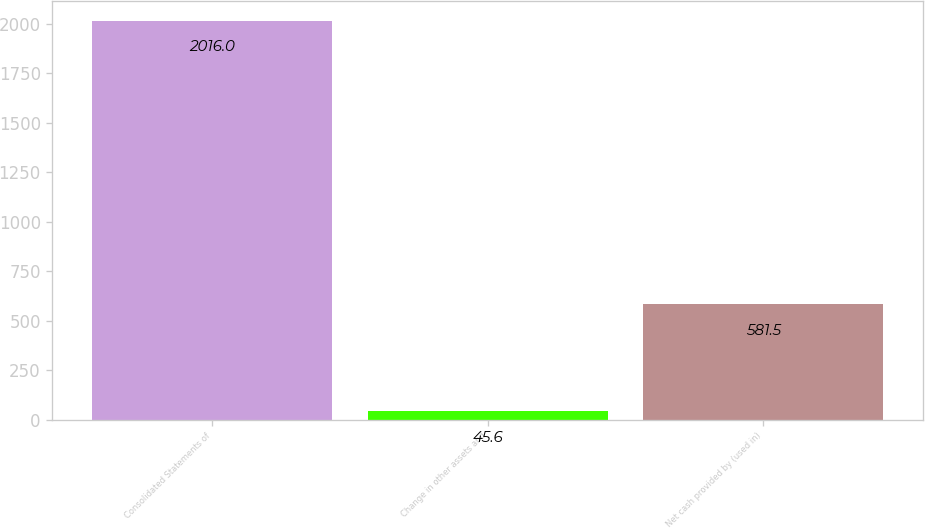Convert chart to OTSL. <chart><loc_0><loc_0><loc_500><loc_500><bar_chart><fcel>Consolidated Statements of<fcel>Change in other assets and<fcel>Net cash provided by (used in)<nl><fcel>2016<fcel>45.6<fcel>581.5<nl></chart> 